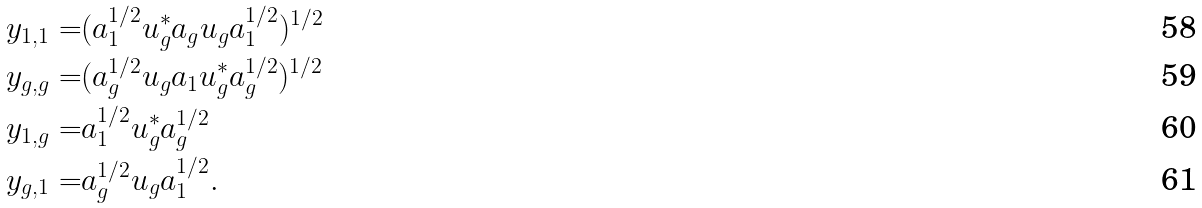<formula> <loc_0><loc_0><loc_500><loc_500>y _ { 1 , 1 } = & ( a _ { 1 } ^ { 1 / 2 } u _ { g } ^ { * } a _ { g } u _ { g } a _ { 1 } ^ { 1 / 2 } ) ^ { 1 / 2 } \\ y _ { g , g } = & ( a _ { g } ^ { 1 / 2 } u _ { g } a _ { 1 } u _ { g } ^ { * } a _ { g } ^ { 1 / 2 } ) ^ { 1 / 2 } \\ y _ { 1 , g } = & a _ { 1 } ^ { 1 / 2 } u _ { g } ^ { * } a _ { g } ^ { 1 / 2 } \\ y _ { g , 1 } = & a _ { g } ^ { 1 / 2 } u _ { g } a _ { 1 } ^ { 1 / 2 } .</formula> 